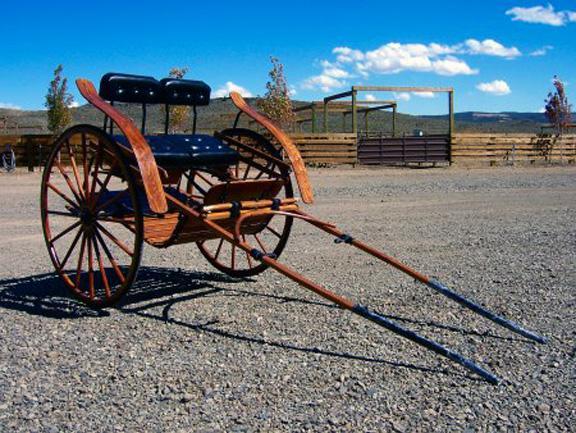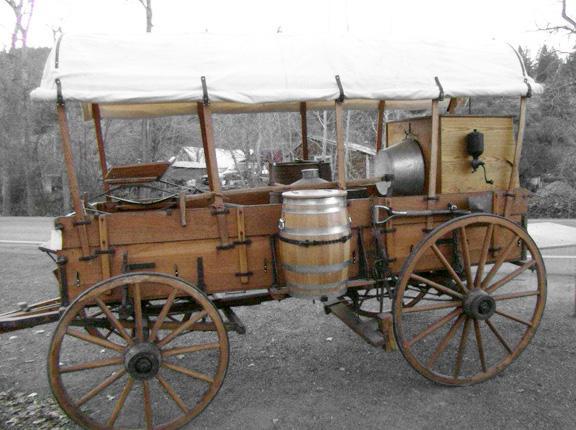The first image is the image on the left, the second image is the image on the right. Assess this claim about the two images: "An image shows a wooden two-wheeled cart with 'handles' tilted to the ground.". Correct or not? Answer yes or no. Yes. The first image is the image on the left, the second image is the image on the right. Considering the images on both sides, is "At least one of the carts is rectagular and made of wood." valid? Answer yes or no. Yes. 